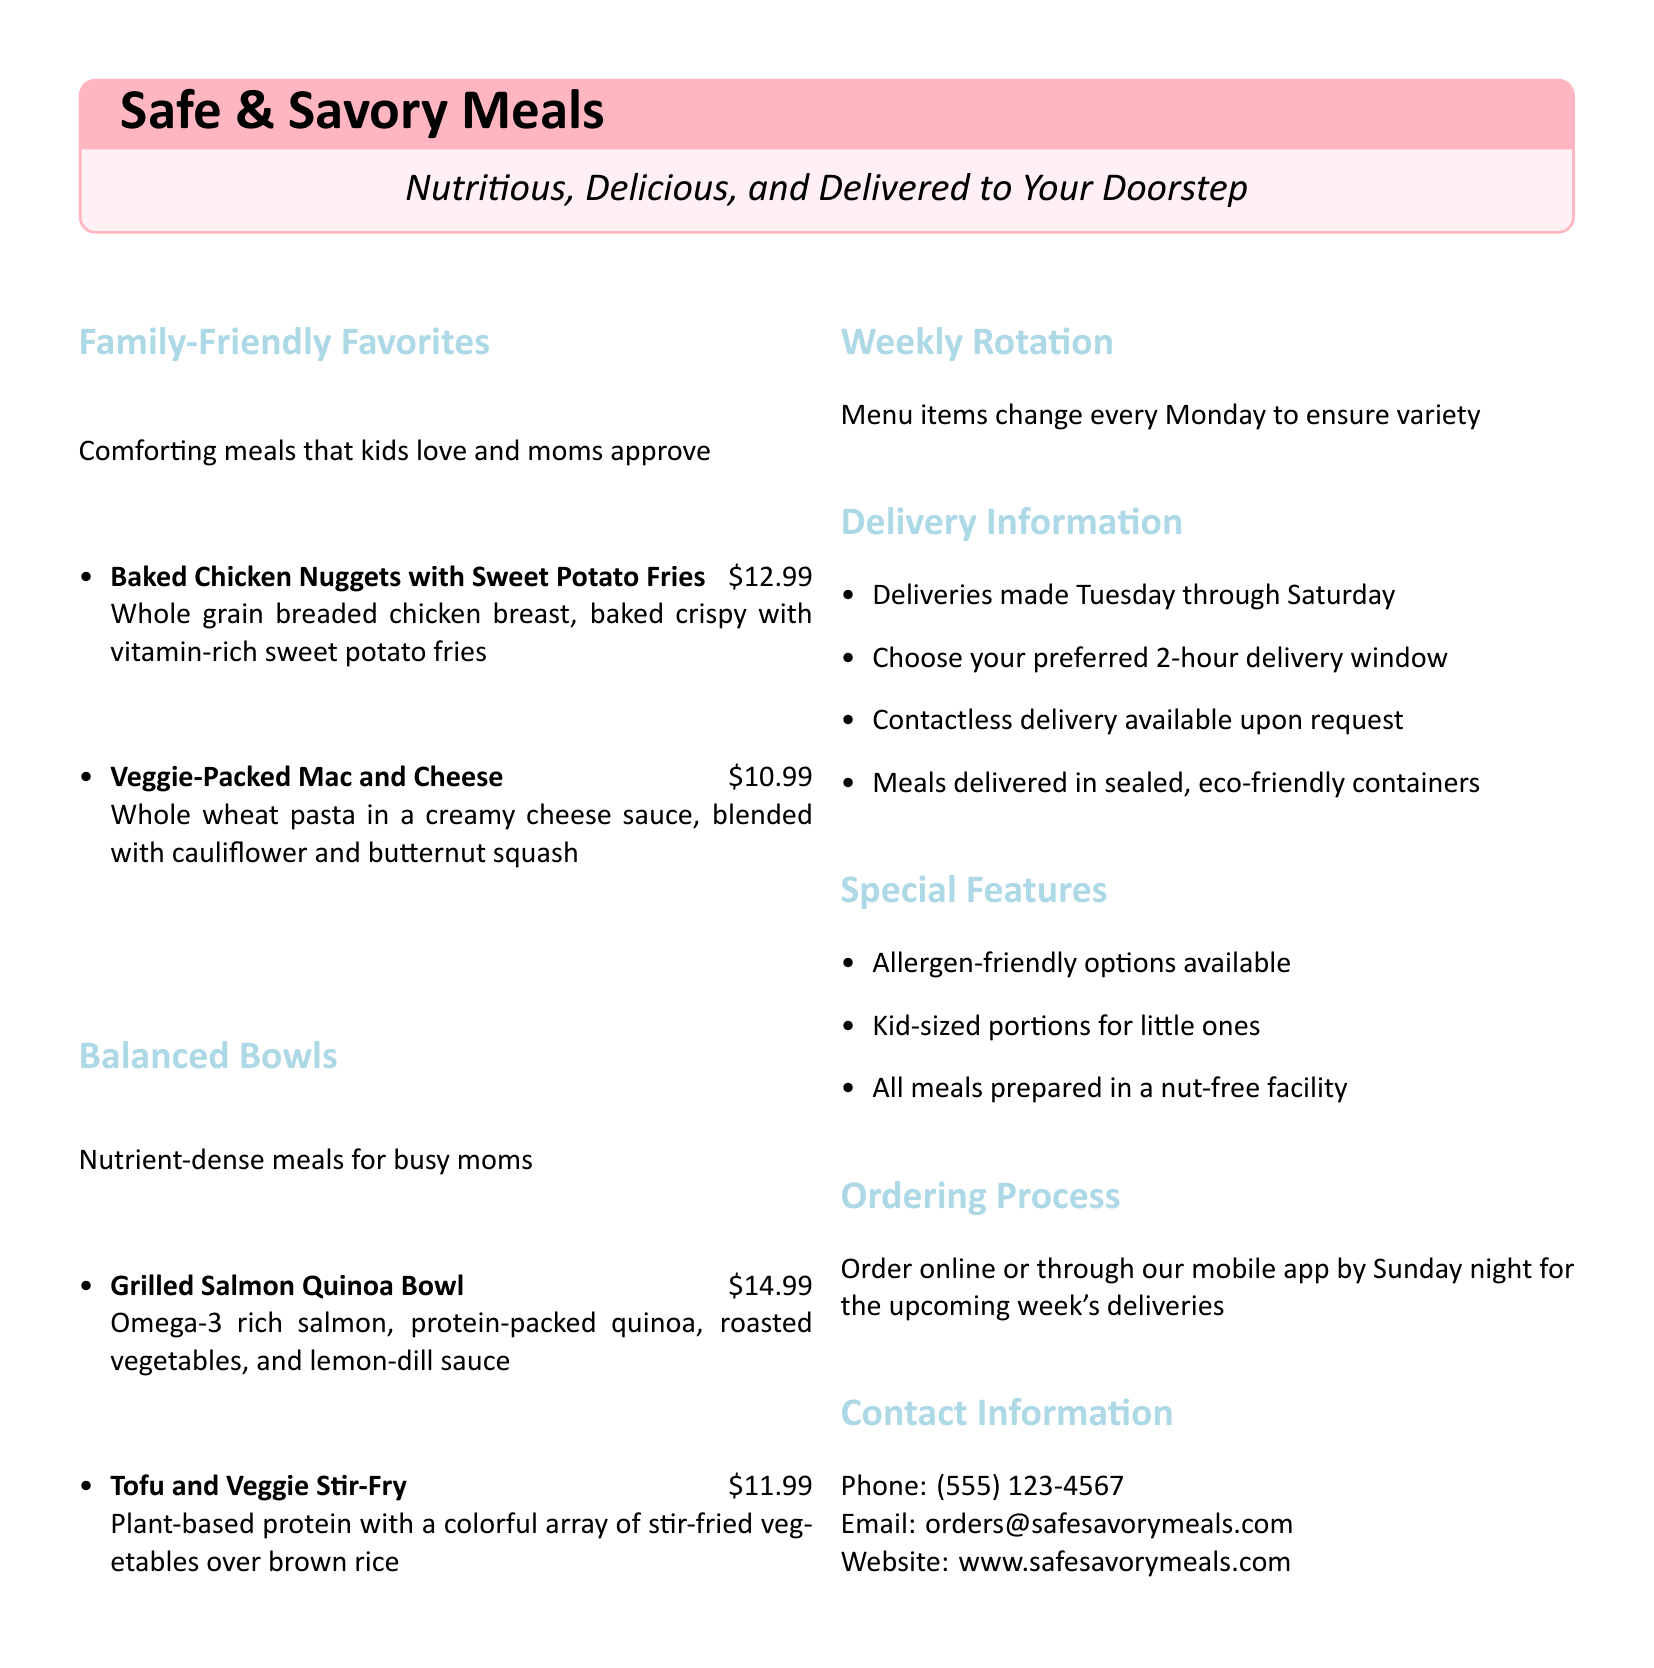what is the name of the meal service? The title of the meal service is prominently displayed at the top of the document.
Answer: Safe & Savory Meals what are the delivery days? The document specifies the days of the week when deliveries are made, which are mentioned in the delivery section.
Answer: Tuesday through Saturday how much does the Grilled Salmon Quinoa Bowl cost? The price of the Grilled Salmon Quinoa Bowl is listed next to the meal description in the menu.
Answer: $14.99 which meal includes sweet potato fries? The meal description lists the components of each meal, identifying which includes sweet potato fries.
Answer: Baked Chicken Nuggets with Sweet Potato Fries how often does the menu rotate? The document states how often the menu items change, giving information about the menu rotation.
Answer: Every Monday what is the contact phone number? The contact information section provides the phone number for inquiries.
Answer: (555) 123-4567 are allergen-friendly options available? The special features of the meal service are outlined in the document, which includes allergen considerations.
Answer: Yes what kind of delivery is available upon request? The delivery section provides options for how meals can be delivered, including alternatives available for customers.
Answer: Contactless delivery how to place an order? The ordering process section explains how customers can place their orders and the deadline for doing so.
Answer: Online or through our mobile app by Sunday night 